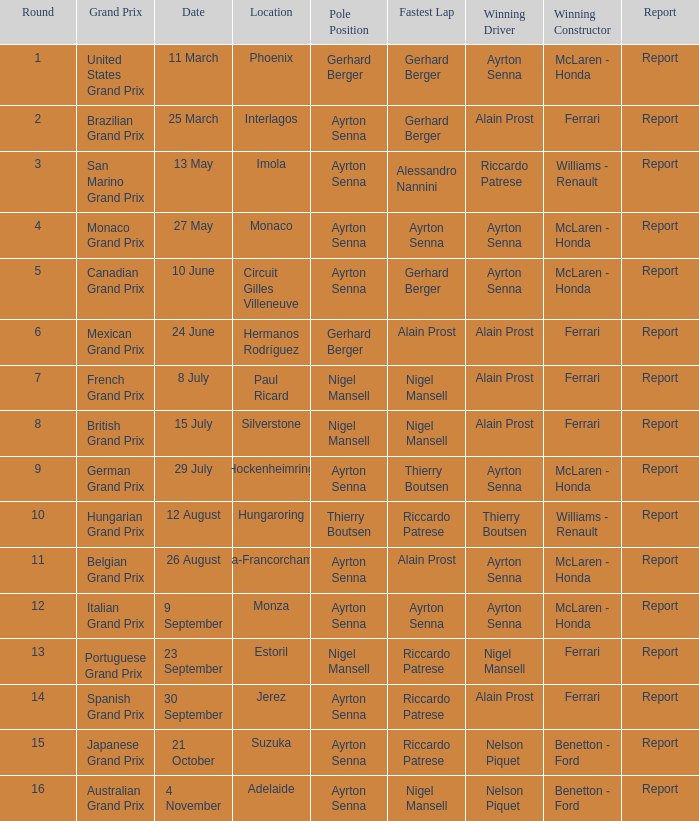Which position is the pole position in the german grand prix? Ayrton Senna. 